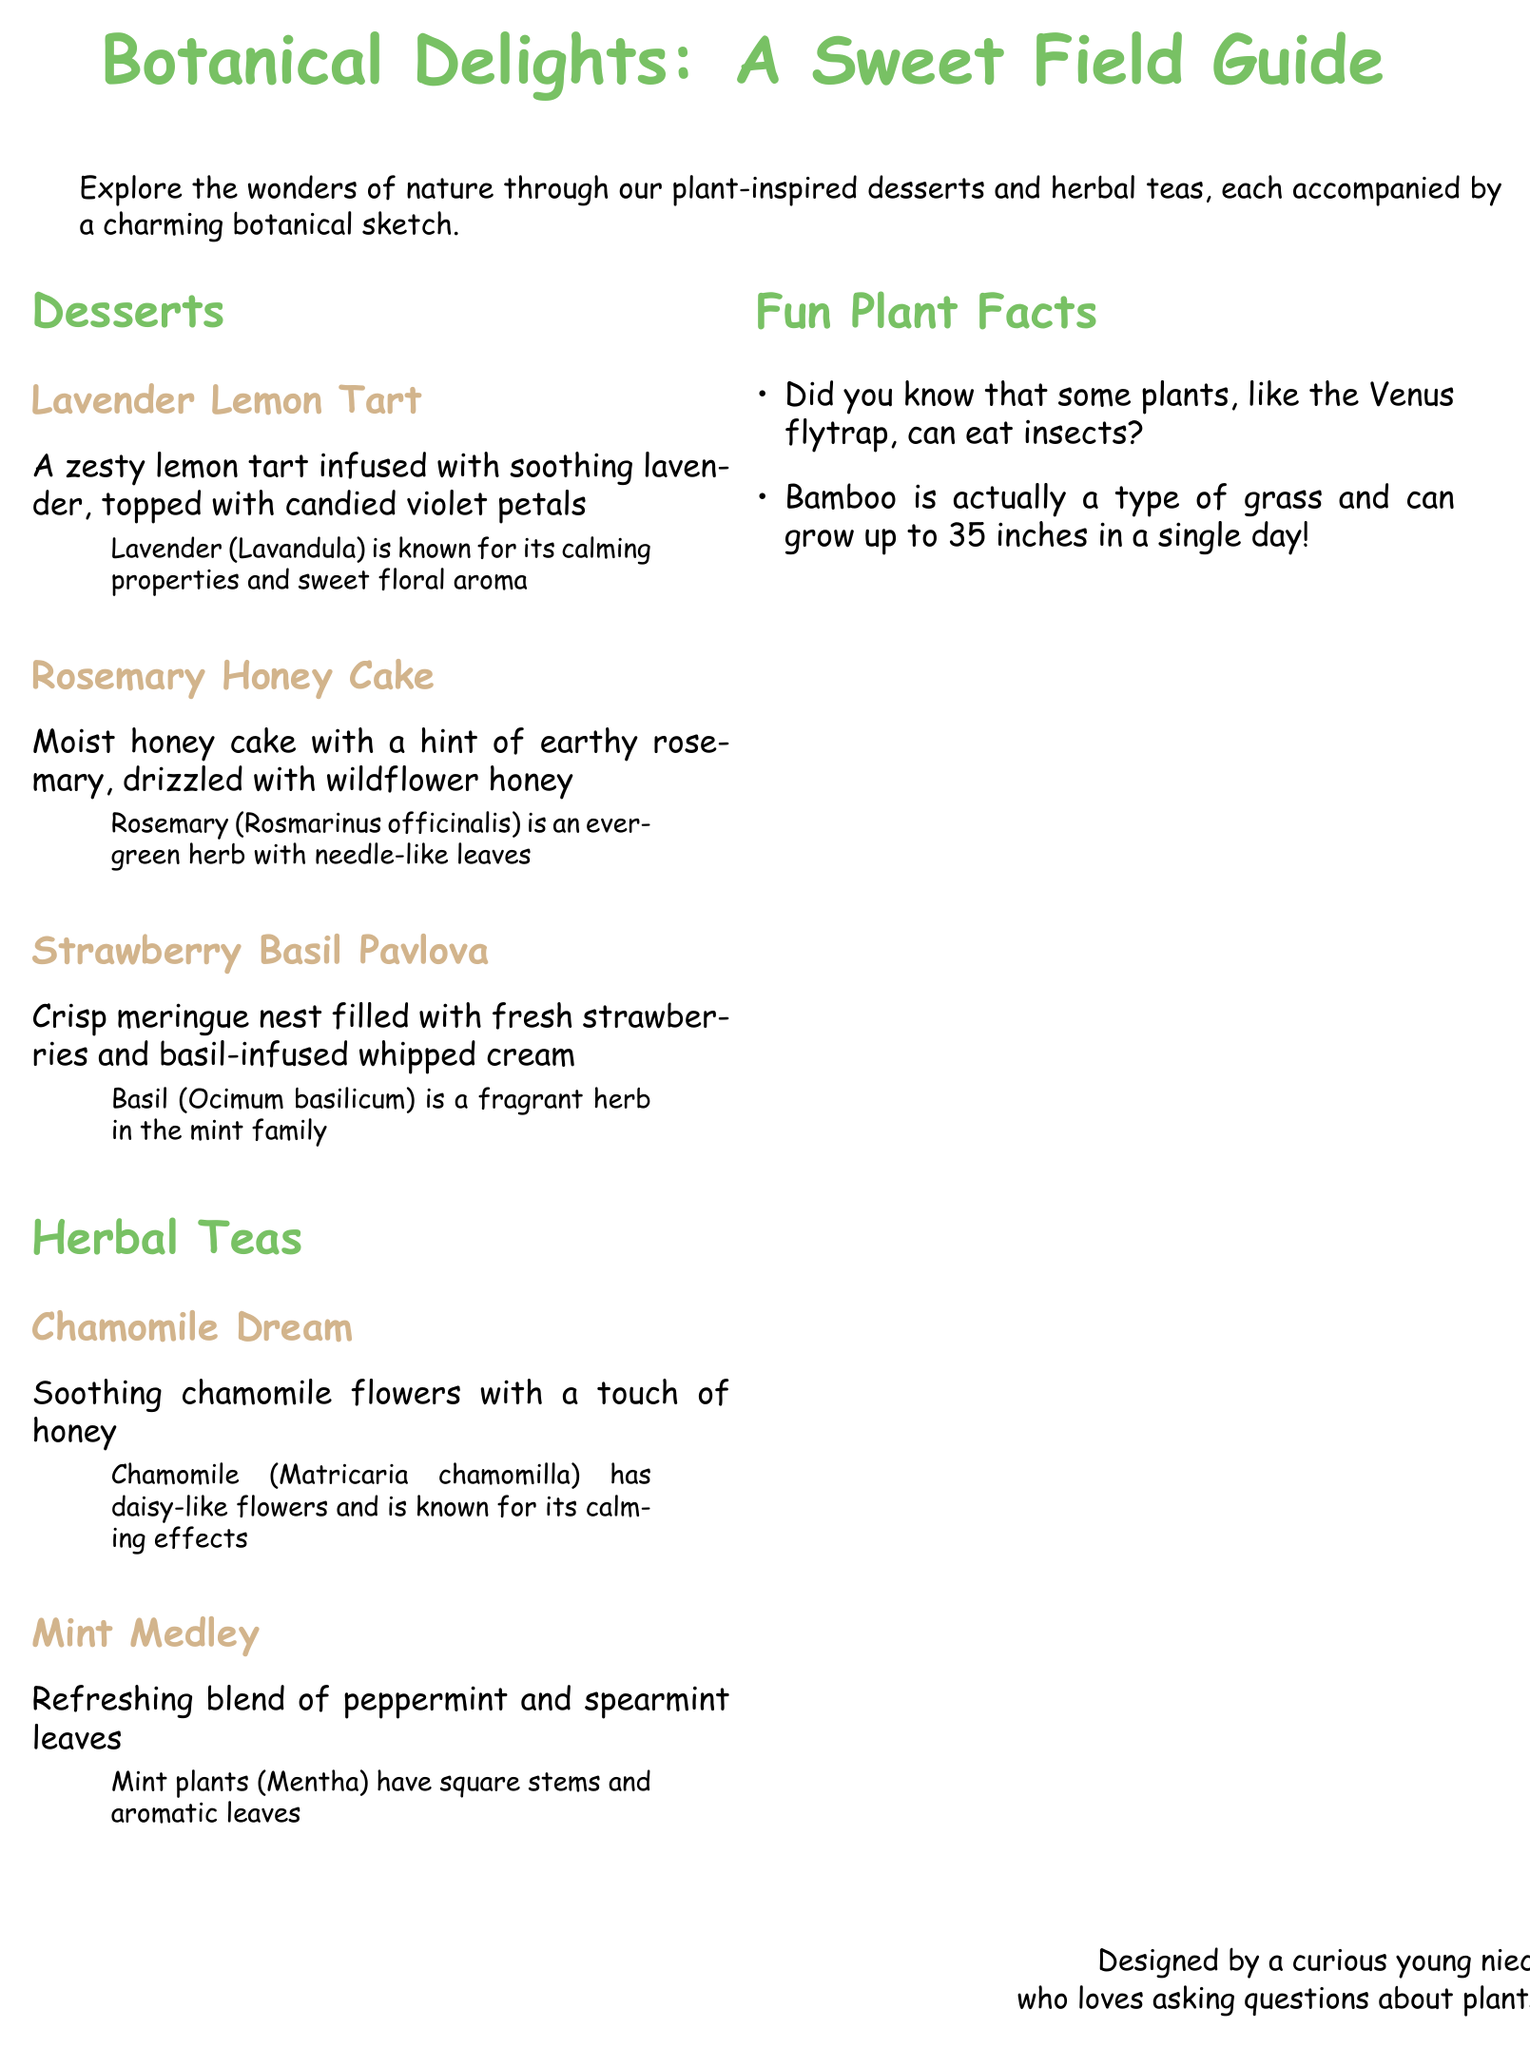What is the title of the menu? The title of the menu is highlighted at the top of the document in large font size.
Answer: Botanical Delights: A Sweet Field Guide Which dessert features candied violet petals? The dessert is specified in the section on desserts, detailing its toppings.
Answer: Lavender Lemon Tart What herb is used in the Rosemary Honey Cake? The document clearly identifies the herb used in this dessert in the description.
Answer: Rosemary How many herbal teas are listed in the menu? The number of herbal teas can be counted in the herbal teas section of the document.
Answer: Two What type of flowers are in the Chamomile Dream tea? The specific flowers mentioned in the tea description provide the answer.
Answer: Chamomile Which dessert is described as having a meringue nest? The information regarding this dessert's structure is found in its description.
Answer: Strawberry Basil Pavlova What color is associated with the section headers? The color of the section headers is defined by the formatting used throughout the document.
Answer: Leaf green What plant family does basil belong to? This information is available in the description of the Strawberry Basil Pavlova.
Answer: Mint family 